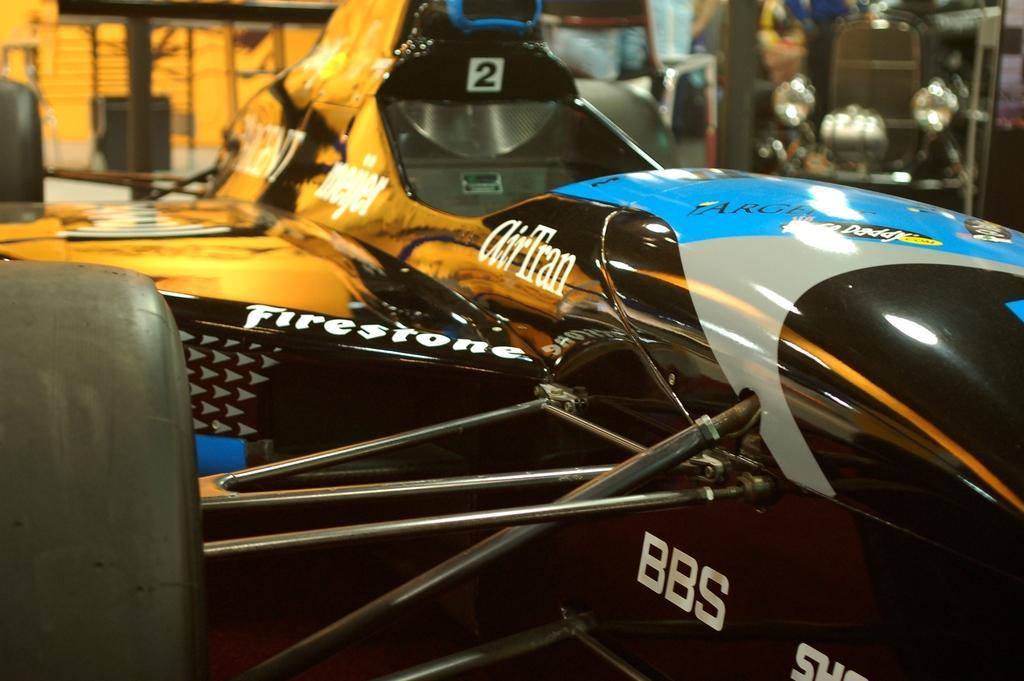Please provide a concise description of this image. The picture consists of a car. The background is blurred. In the background there are cars. 